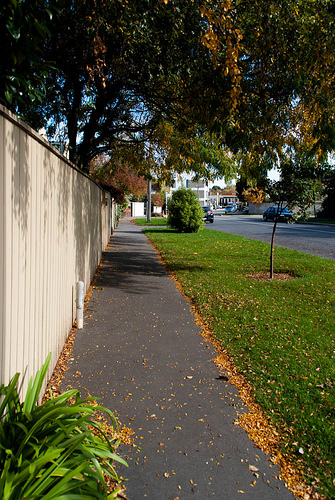<image>
Can you confirm if the path is under the fence? No. The path is not positioned under the fence. The vertical relationship between these objects is different. Is there a sidewalk to the right of the fence? Yes. From this viewpoint, the sidewalk is positioned to the right side relative to the fence. 